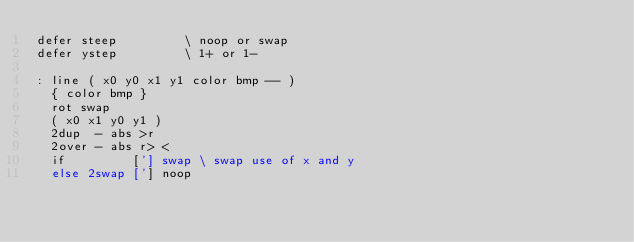Convert code to text. <code><loc_0><loc_0><loc_500><loc_500><_Forth_>defer steep         \ noop or swap
defer ystep         \ 1+ or 1-

: line ( x0 y0 x1 y1 color bmp -- )
  { color bmp }
  rot swap
  ( x0 x1 y0 y1 )
  2dup  - abs >r
  2over - abs r> <
  if         ['] swap \ swap use of x and y
  else 2swap ['] noop</code> 